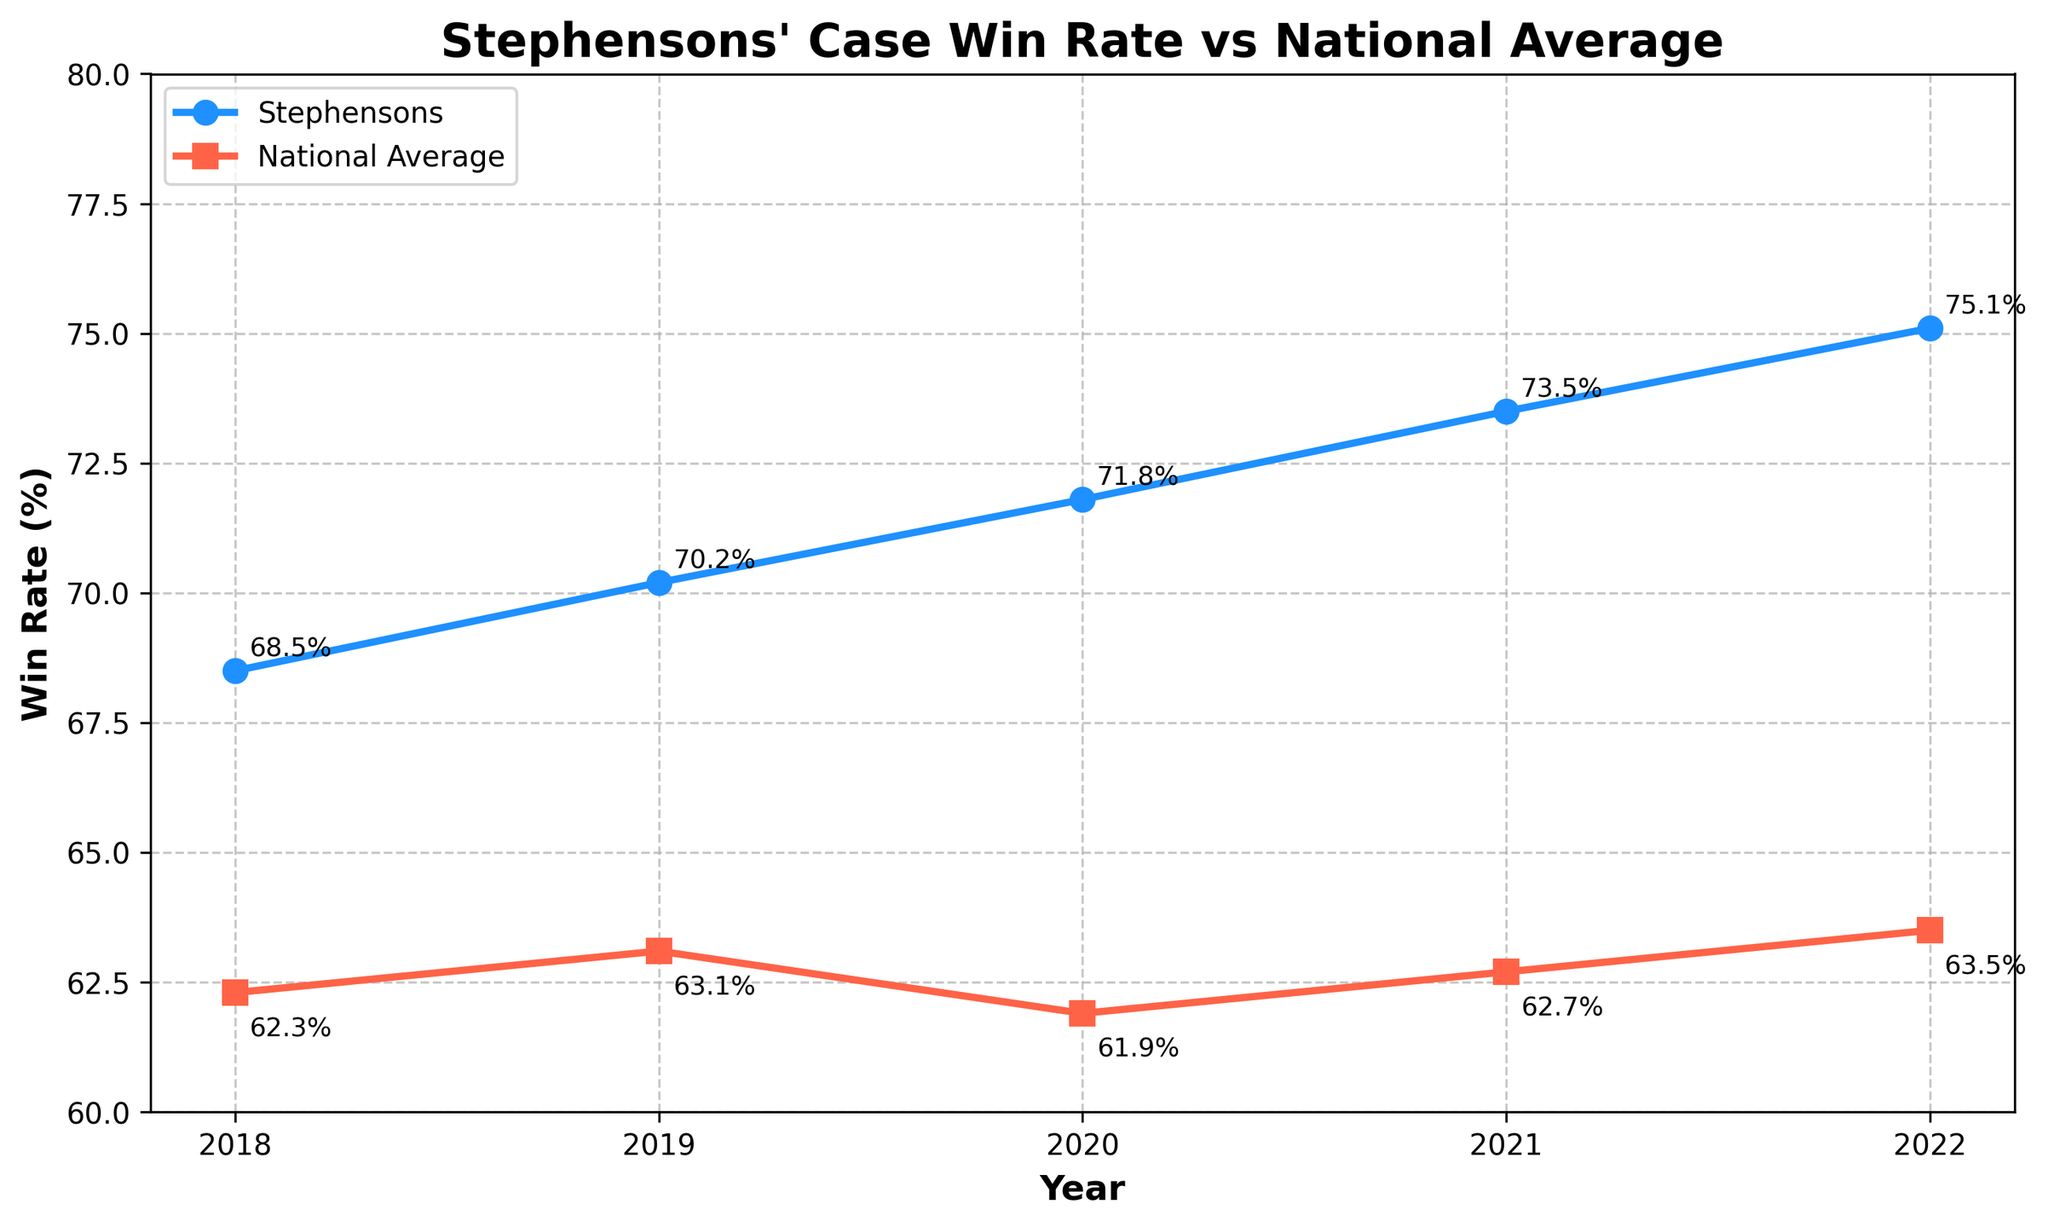What's the overall trend of Stephensons' win rate over the last five years? The series of win rates from 2018 to 2022 is consistently increasing. This is seen with values of 68.5%, 70.2%, 71.8%, 73.5%, and 75.1%. Each year shows a higher value compared to the previous year.
Answer: It is consistently increasing How does the national average win rate in 2020 compare to the national average win rate in 2022? The national average win rate in 2020 was 61.9%, and in 2022 it was 63.5%. By subtracting 61.9% from 63.5%, we find that the win rate increased by 1.6%.
Answer: It increased by 1.6% What is the maximum difference observed between Stephensons' win rate and the national average win rate in any year? We calculate the differences for each year: 2018 (68.5% - 62.3% = 6.2%), 2019 (70.2% - 63.1% = 7.1%), 2020 (71.8% - 61.9% = 9.9%), 2021 (73.5% - 62.7% = 10.8%), and 2022 (75.1% - 63.5% = 11.6%). The maximum difference is 11.6% in 2022.
Answer: 11.6% In which year did Stephensons have the smallest lead over the national average win rate? We compare the differences: 2018 (6.2%), 2019 (7.1%), 2020 (9.9%), 2021 (10.8%), and 2022 (11.6%). The smallest difference is in 2018, with 6.2%.
Answer: 2018 Compare the slope of the trend lines for Stephensons' win rate and the national average win rate. Which one shows a steeper rate of change? Stephensons' win rate increased from 68.5% to 75.1% (a change of 6.6%) over 5 years. The national average went from 62.3% to 63.5% (a change of 1.2%) over the same period. Dividing these changes by 5 years, we see Stephensons' rate of change is 1.32% per year, while the national average is 0.24% per year. Stephensons shows a steeper rate of change.
Answer: Stephensons What were the win rates for both Stephensons and the national average in 2019? From the chart, Stephensons' win rate in 2019 is 70.2%, and the national average win rate is 63.1%.
Answer: 70.2%, 63.1% By how much did Stephensons' win rate improve from 2018 to 2022? Stephensons' win rate in 2018 was 68.5%, and in 2022 it was 75.1%. The improvement is 75.1% - 68.5% = 6.6%.
Answer: 6.6% Which year had the highest national average win rate, and what was the value? The highest national average win rate observed is in 2022, with a value of 63.5%.
Answer: 2022, 63.5% In which year was the gap between Stephensons' win rate and the national average win rate the largest? To find the largest gap, compare the differences each year: 2018 (6.2%), 2019 (7.1%), 2020 (9.9%), 2021 (10.8%), and 2022 (11.6%). The largest gap is in 2022 with 11.6%.
Answer: 2022 